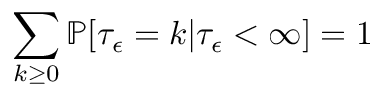<formula> <loc_0><loc_0><loc_500><loc_500>\sum _ { k \geq 0 } \mathbb { P } [ \tau _ { \epsilon } = k | \tau _ { \epsilon } < \infty ] = 1</formula> 